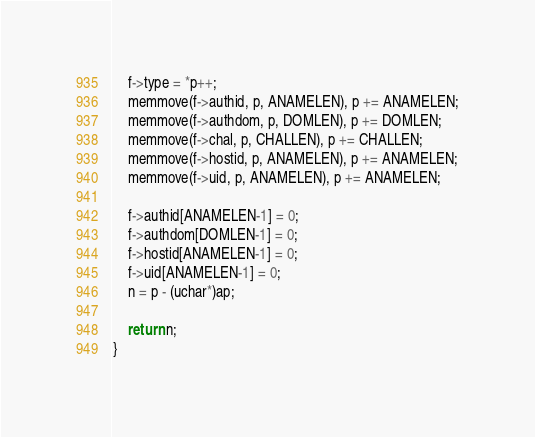<code> <loc_0><loc_0><loc_500><loc_500><_C_>	f->type = *p++;
	memmove(f->authid, p, ANAMELEN), p += ANAMELEN;
	memmove(f->authdom, p, DOMLEN), p += DOMLEN;
	memmove(f->chal, p, CHALLEN), p += CHALLEN;
	memmove(f->hostid, p, ANAMELEN), p += ANAMELEN;
	memmove(f->uid, p, ANAMELEN), p += ANAMELEN;

	f->authid[ANAMELEN-1] = 0;
	f->authdom[DOMLEN-1] = 0;
	f->hostid[ANAMELEN-1] = 0;
	f->uid[ANAMELEN-1] = 0;
	n = p - (uchar*)ap;

	return n;
}
</code> 